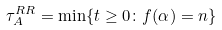<formula> <loc_0><loc_0><loc_500><loc_500>\tau ^ { R R } _ { A } = \min \{ t \geq 0 \colon f ( \alpha ) = n \}</formula> 